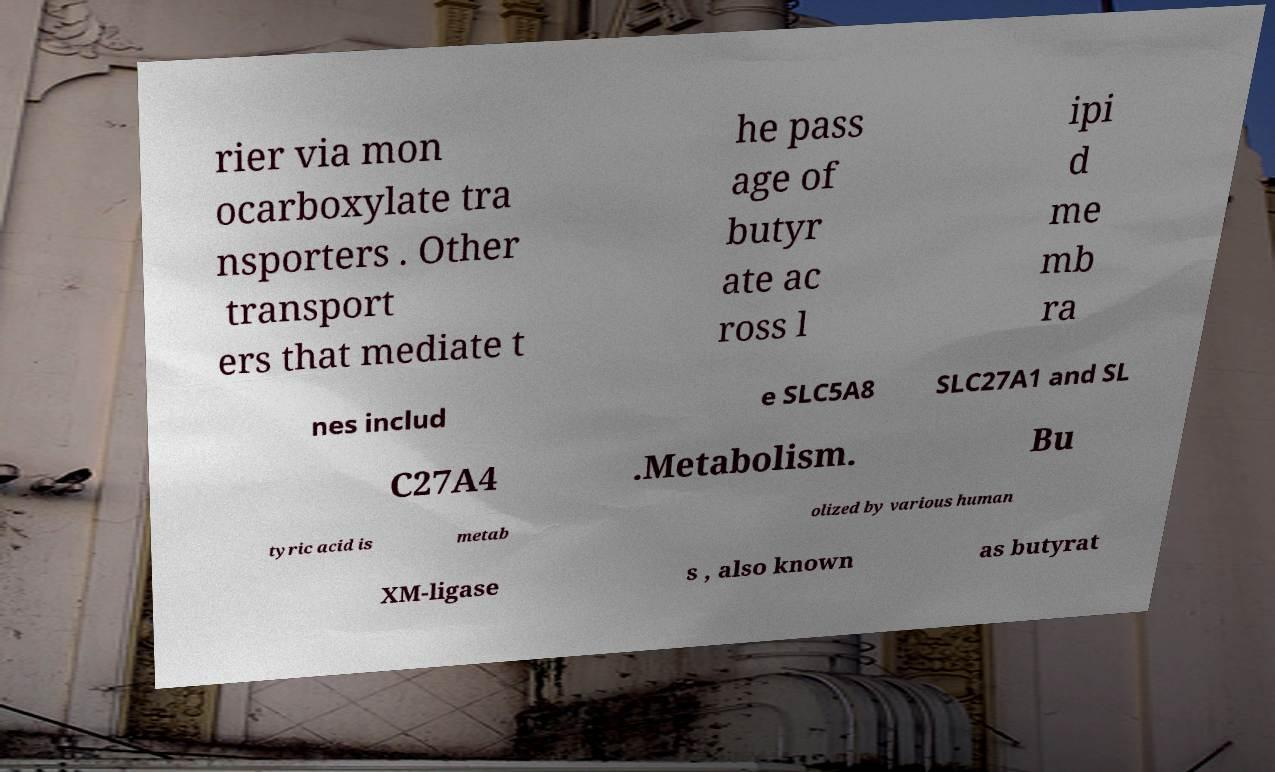Could you extract and type out the text from this image? rier via mon ocarboxylate tra nsporters . Other transport ers that mediate t he pass age of butyr ate ac ross l ipi d me mb ra nes includ e SLC5A8 SLC27A1 and SL C27A4 .Metabolism. Bu tyric acid is metab olized by various human XM-ligase s , also known as butyrat 